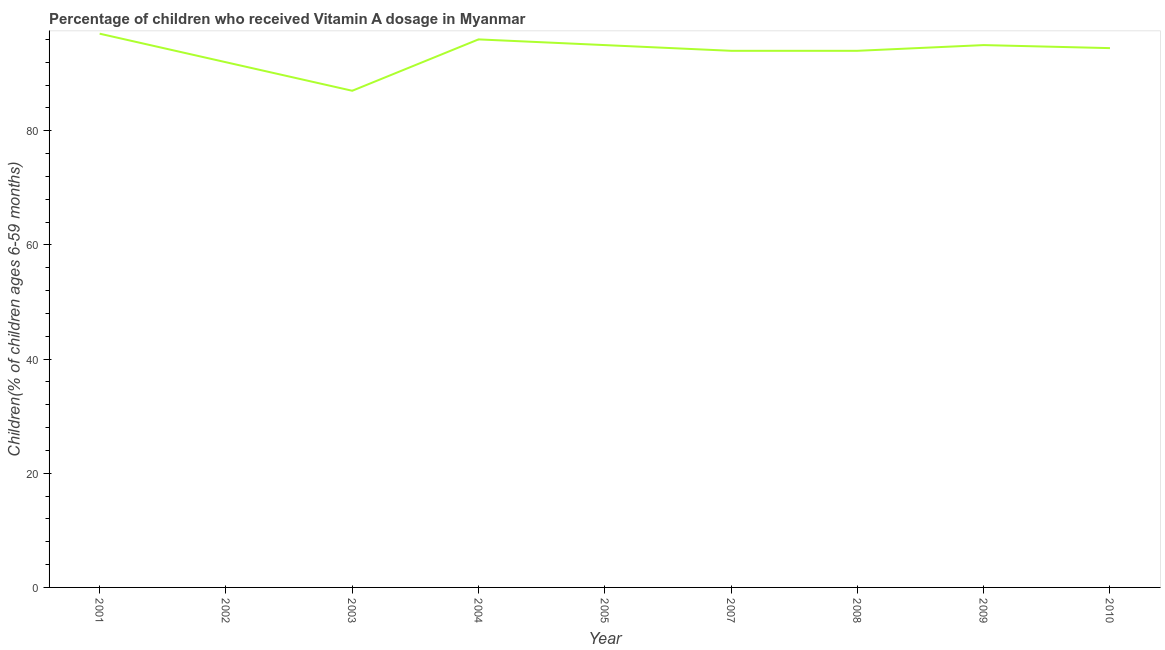Across all years, what is the maximum vitamin a supplementation coverage rate?
Give a very brief answer. 97. Across all years, what is the minimum vitamin a supplementation coverage rate?
Provide a short and direct response. 87. What is the sum of the vitamin a supplementation coverage rate?
Give a very brief answer. 844.47. What is the average vitamin a supplementation coverage rate per year?
Give a very brief answer. 93.83. What is the median vitamin a supplementation coverage rate?
Offer a terse response. 94.47. In how many years, is the vitamin a supplementation coverage rate greater than 12 %?
Ensure brevity in your answer.  9. What is the ratio of the vitamin a supplementation coverage rate in 2004 to that in 2010?
Offer a very short reply. 1.02. Is the vitamin a supplementation coverage rate in 2003 less than that in 2005?
Keep it short and to the point. Yes. Is the difference between the vitamin a supplementation coverage rate in 2002 and 2007 greater than the difference between any two years?
Your answer should be compact. No. Is the sum of the vitamin a supplementation coverage rate in 2009 and 2010 greater than the maximum vitamin a supplementation coverage rate across all years?
Give a very brief answer. Yes. In how many years, is the vitamin a supplementation coverage rate greater than the average vitamin a supplementation coverage rate taken over all years?
Give a very brief answer. 7. Does the vitamin a supplementation coverage rate monotonically increase over the years?
Provide a succinct answer. No. Are the values on the major ticks of Y-axis written in scientific E-notation?
Your answer should be very brief. No. Does the graph contain grids?
Ensure brevity in your answer.  No. What is the title of the graph?
Give a very brief answer. Percentage of children who received Vitamin A dosage in Myanmar. What is the label or title of the Y-axis?
Your answer should be compact. Children(% of children ages 6-59 months). What is the Children(% of children ages 6-59 months) of 2001?
Ensure brevity in your answer.  97. What is the Children(% of children ages 6-59 months) of 2002?
Your answer should be very brief. 92. What is the Children(% of children ages 6-59 months) in 2004?
Make the answer very short. 96. What is the Children(% of children ages 6-59 months) of 2005?
Your answer should be very brief. 95. What is the Children(% of children ages 6-59 months) of 2007?
Provide a succinct answer. 94. What is the Children(% of children ages 6-59 months) in 2008?
Your response must be concise. 94. What is the Children(% of children ages 6-59 months) in 2010?
Make the answer very short. 94.47. What is the difference between the Children(% of children ages 6-59 months) in 2001 and 2004?
Provide a short and direct response. 1. What is the difference between the Children(% of children ages 6-59 months) in 2001 and 2007?
Your response must be concise. 3. What is the difference between the Children(% of children ages 6-59 months) in 2001 and 2008?
Give a very brief answer. 3. What is the difference between the Children(% of children ages 6-59 months) in 2001 and 2010?
Keep it short and to the point. 2.53. What is the difference between the Children(% of children ages 6-59 months) in 2002 and 2003?
Ensure brevity in your answer.  5. What is the difference between the Children(% of children ages 6-59 months) in 2002 and 2004?
Provide a short and direct response. -4. What is the difference between the Children(% of children ages 6-59 months) in 2002 and 2007?
Your answer should be very brief. -2. What is the difference between the Children(% of children ages 6-59 months) in 2002 and 2009?
Your response must be concise. -3. What is the difference between the Children(% of children ages 6-59 months) in 2002 and 2010?
Ensure brevity in your answer.  -2.47. What is the difference between the Children(% of children ages 6-59 months) in 2003 and 2008?
Your answer should be compact. -7. What is the difference between the Children(% of children ages 6-59 months) in 2003 and 2010?
Provide a short and direct response. -7.47. What is the difference between the Children(% of children ages 6-59 months) in 2004 and 2005?
Your answer should be compact. 1. What is the difference between the Children(% of children ages 6-59 months) in 2004 and 2007?
Make the answer very short. 2. What is the difference between the Children(% of children ages 6-59 months) in 2004 and 2010?
Provide a succinct answer. 1.53. What is the difference between the Children(% of children ages 6-59 months) in 2005 and 2009?
Provide a short and direct response. 0. What is the difference between the Children(% of children ages 6-59 months) in 2005 and 2010?
Your response must be concise. 0.53. What is the difference between the Children(% of children ages 6-59 months) in 2007 and 2008?
Your answer should be very brief. 0. What is the difference between the Children(% of children ages 6-59 months) in 2007 and 2010?
Offer a very short reply. -0.47. What is the difference between the Children(% of children ages 6-59 months) in 2008 and 2010?
Make the answer very short. -0.47. What is the difference between the Children(% of children ages 6-59 months) in 2009 and 2010?
Make the answer very short. 0.53. What is the ratio of the Children(% of children ages 6-59 months) in 2001 to that in 2002?
Keep it short and to the point. 1.05. What is the ratio of the Children(% of children ages 6-59 months) in 2001 to that in 2003?
Make the answer very short. 1.11. What is the ratio of the Children(% of children ages 6-59 months) in 2001 to that in 2005?
Offer a terse response. 1.02. What is the ratio of the Children(% of children ages 6-59 months) in 2001 to that in 2007?
Offer a very short reply. 1.03. What is the ratio of the Children(% of children ages 6-59 months) in 2001 to that in 2008?
Your answer should be very brief. 1.03. What is the ratio of the Children(% of children ages 6-59 months) in 2001 to that in 2010?
Provide a succinct answer. 1.03. What is the ratio of the Children(% of children ages 6-59 months) in 2002 to that in 2003?
Your answer should be compact. 1.06. What is the ratio of the Children(% of children ages 6-59 months) in 2002 to that in 2004?
Ensure brevity in your answer.  0.96. What is the ratio of the Children(% of children ages 6-59 months) in 2002 to that in 2010?
Ensure brevity in your answer.  0.97. What is the ratio of the Children(% of children ages 6-59 months) in 2003 to that in 2004?
Offer a very short reply. 0.91. What is the ratio of the Children(% of children ages 6-59 months) in 2003 to that in 2005?
Your answer should be compact. 0.92. What is the ratio of the Children(% of children ages 6-59 months) in 2003 to that in 2007?
Your response must be concise. 0.93. What is the ratio of the Children(% of children ages 6-59 months) in 2003 to that in 2008?
Give a very brief answer. 0.93. What is the ratio of the Children(% of children ages 6-59 months) in 2003 to that in 2009?
Your answer should be very brief. 0.92. What is the ratio of the Children(% of children ages 6-59 months) in 2003 to that in 2010?
Ensure brevity in your answer.  0.92. What is the ratio of the Children(% of children ages 6-59 months) in 2004 to that in 2007?
Provide a succinct answer. 1.02. What is the ratio of the Children(% of children ages 6-59 months) in 2005 to that in 2008?
Offer a very short reply. 1.01. What is the ratio of the Children(% of children ages 6-59 months) in 2005 to that in 2009?
Provide a succinct answer. 1. What is the ratio of the Children(% of children ages 6-59 months) in 2007 to that in 2008?
Provide a succinct answer. 1. What is the ratio of the Children(% of children ages 6-59 months) in 2007 to that in 2009?
Your response must be concise. 0.99. What is the ratio of the Children(% of children ages 6-59 months) in 2007 to that in 2010?
Offer a very short reply. 0.99. What is the ratio of the Children(% of children ages 6-59 months) in 2008 to that in 2009?
Offer a terse response. 0.99. What is the ratio of the Children(% of children ages 6-59 months) in 2008 to that in 2010?
Offer a terse response. 0.99. What is the ratio of the Children(% of children ages 6-59 months) in 2009 to that in 2010?
Offer a terse response. 1.01. 